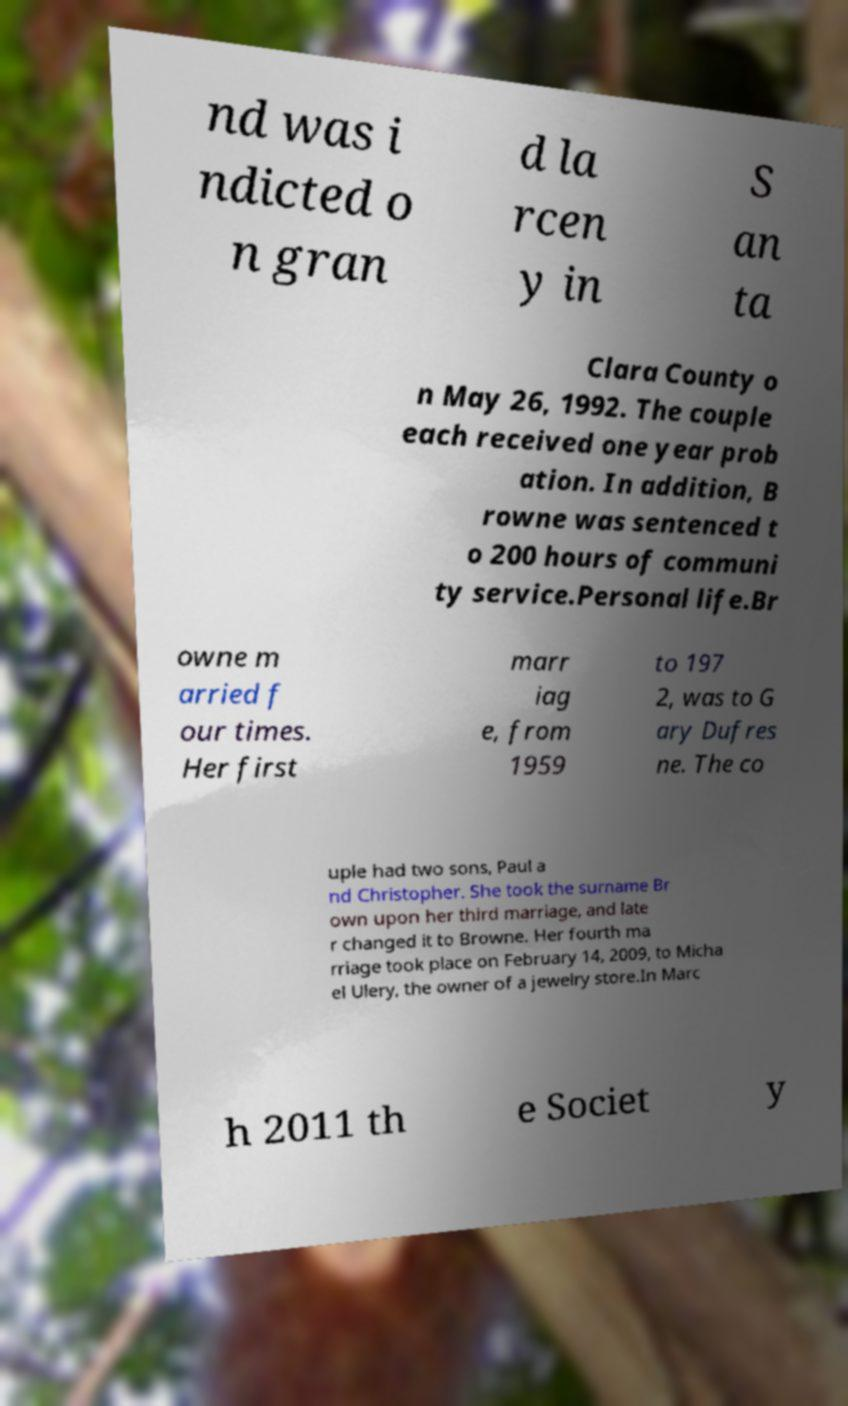Please read and relay the text visible in this image. What does it say? nd was i ndicted o n gran d la rcen y in S an ta Clara County o n May 26, 1992. The couple each received one year prob ation. In addition, B rowne was sentenced t o 200 hours of communi ty service.Personal life.Br owne m arried f our times. Her first marr iag e, from 1959 to 197 2, was to G ary Dufres ne. The co uple had two sons, Paul a nd Christopher. She took the surname Br own upon her third marriage, and late r changed it to Browne. Her fourth ma rriage took place on February 14, 2009, to Micha el Ulery, the owner of a jewelry store.In Marc h 2011 th e Societ y 